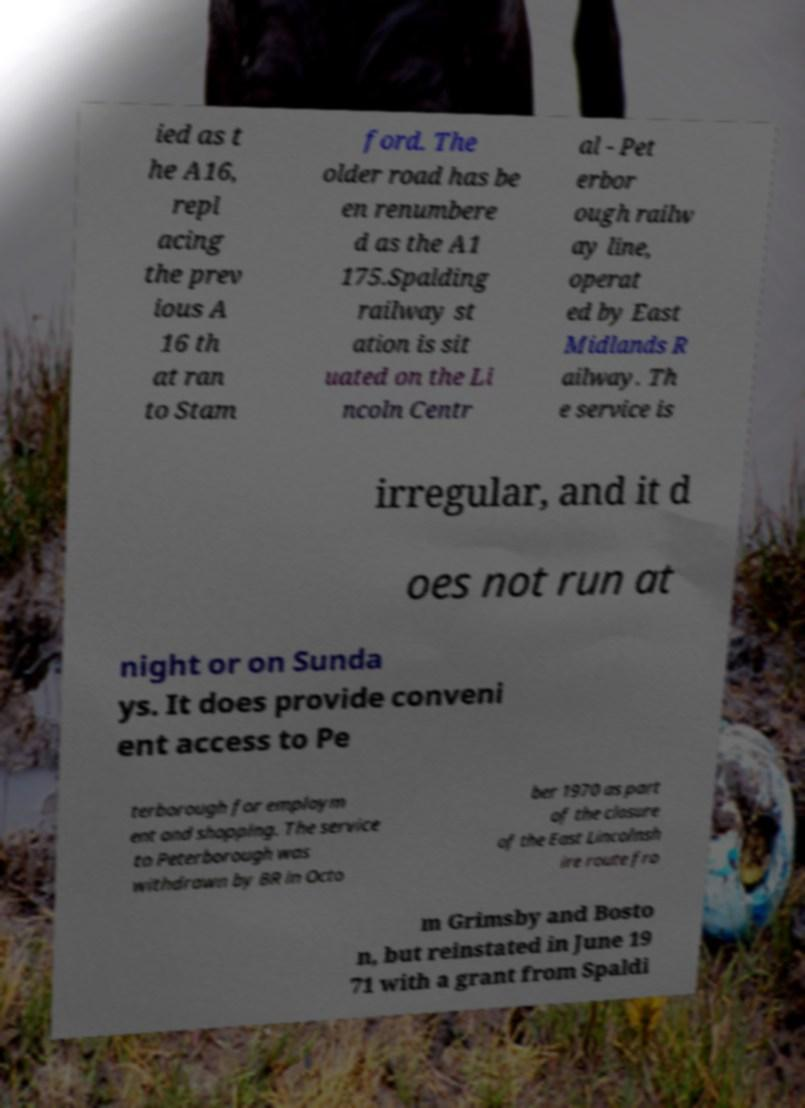Please identify and transcribe the text found in this image. ied as t he A16, repl acing the prev ious A 16 th at ran to Stam ford. The older road has be en renumbere d as the A1 175.Spalding railway st ation is sit uated on the Li ncoln Centr al - Pet erbor ough railw ay line, operat ed by East Midlands R ailway. Th e service is irregular, and it d oes not run at night or on Sunda ys. It does provide conveni ent access to Pe terborough for employm ent and shopping. The service to Peterborough was withdrawn by BR in Octo ber 1970 as part of the closure of the East Lincolnsh ire route fro m Grimsby and Bosto n, but reinstated in June 19 71 with a grant from Spaldi 